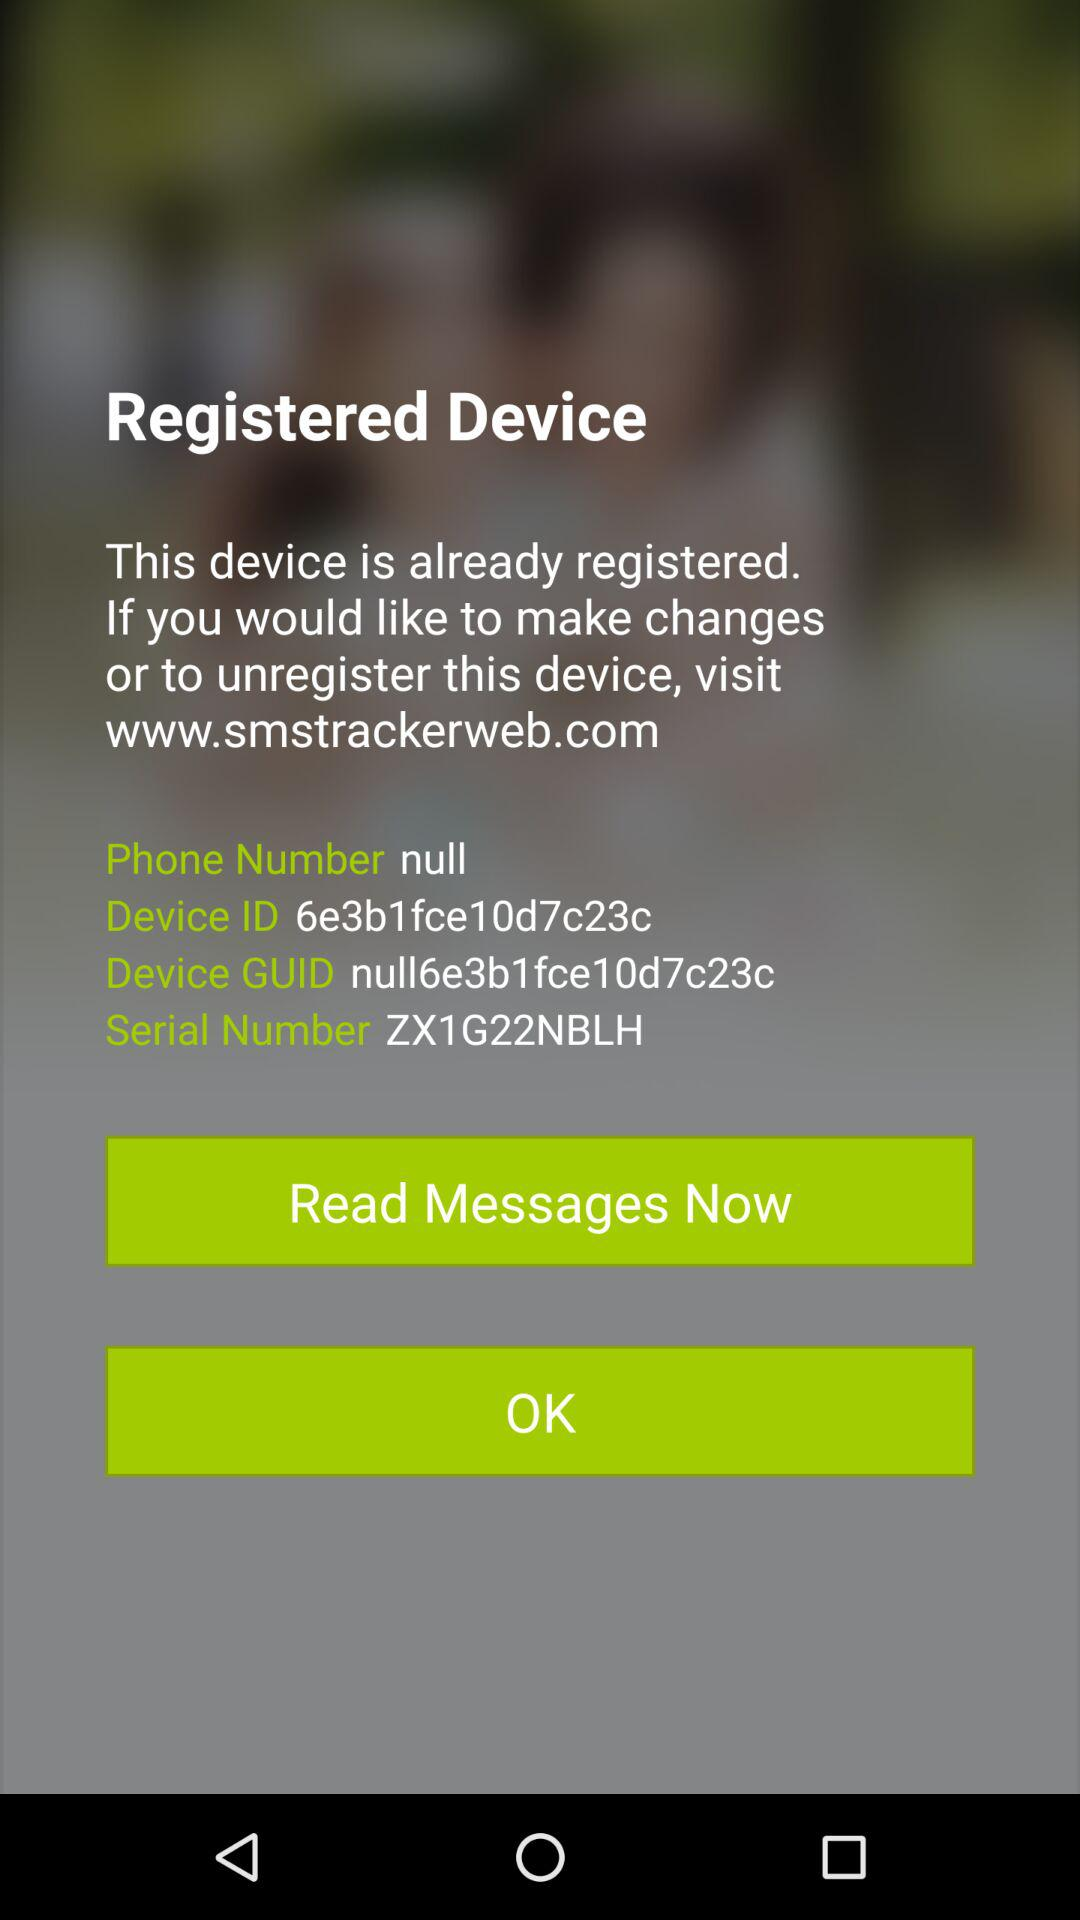What is the device serial number? The device serial number is ZX1G22NBLH. 